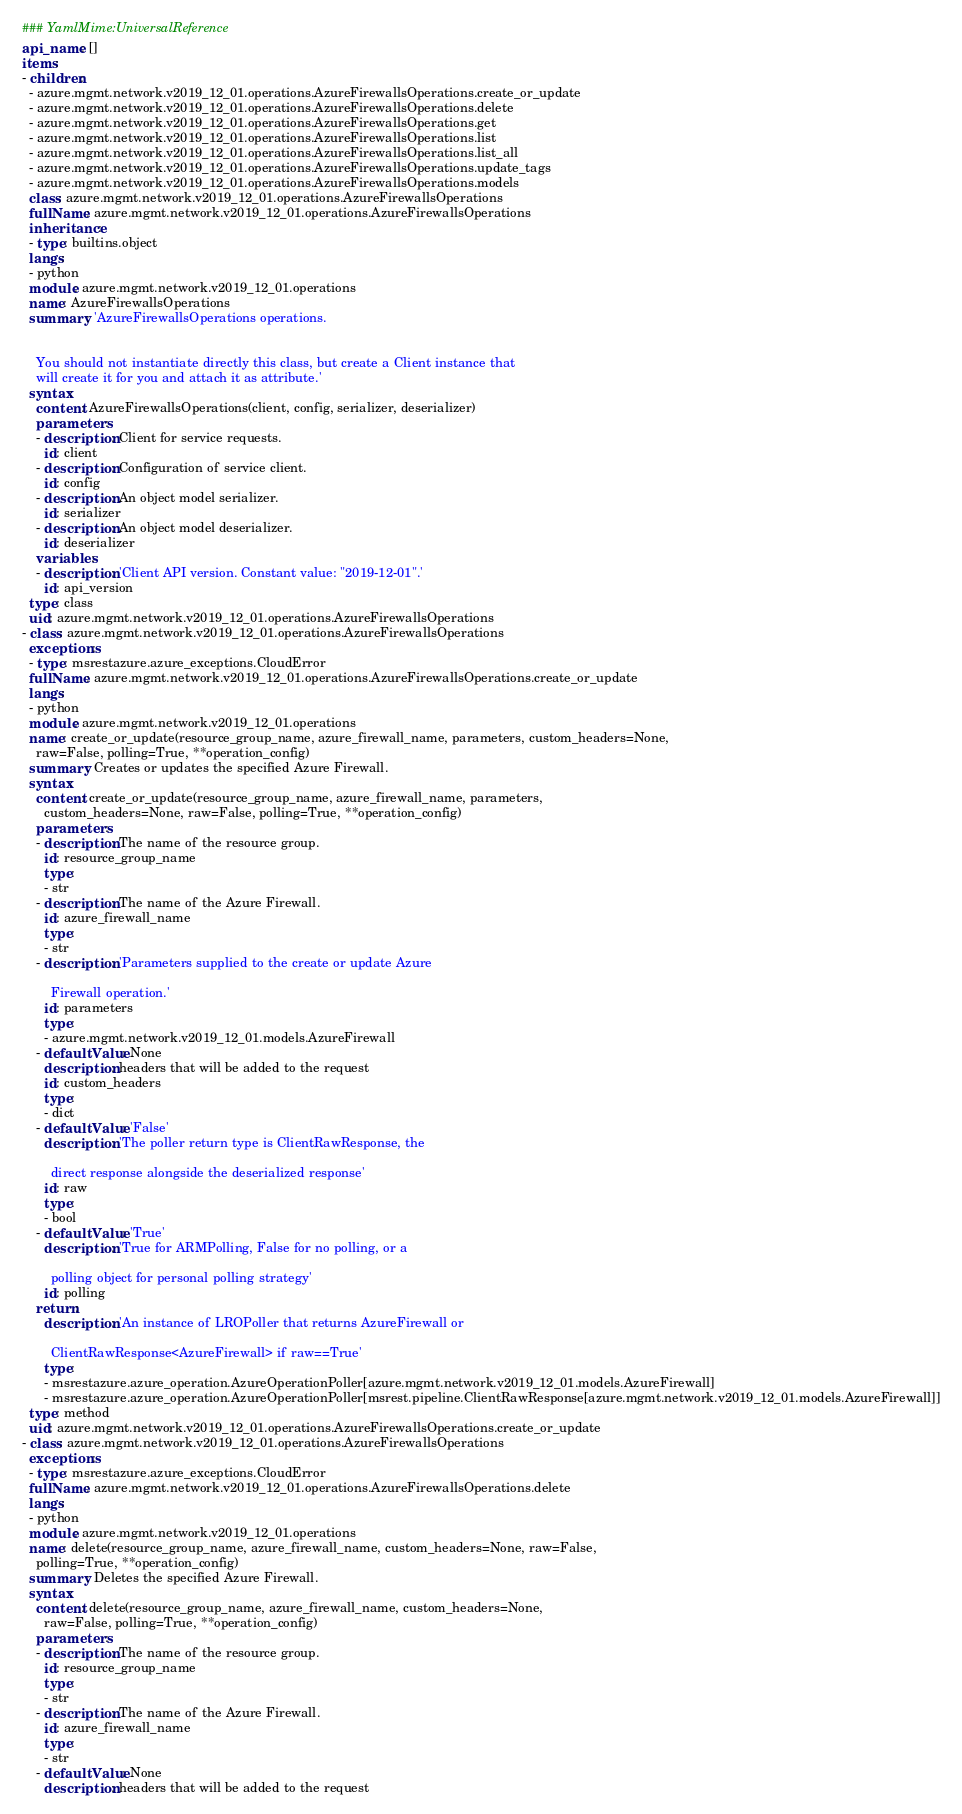Convert code to text. <code><loc_0><loc_0><loc_500><loc_500><_YAML_>### YamlMime:UniversalReference
api_name: []
items:
- children:
  - azure.mgmt.network.v2019_12_01.operations.AzureFirewallsOperations.create_or_update
  - azure.mgmt.network.v2019_12_01.operations.AzureFirewallsOperations.delete
  - azure.mgmt.network.v2019_12_01.operations.AzureFirewallsOperations.get
  - azure.mgmt.network.v2019_12_01.operations.AzureFirewallsOperations.list
  - azure.mgmt.network.v2019_12_01.operations.AzureFirewallsOperations.list_all
  - azure.mgmt.network.v2019_12_01.operations.AzureFirewallsOperations.update_tags
  - azure.mgmt.network.v2019_12_01.operations.AzureFirewallsOperations.models
  class: azure.mgmt.network.v2019_12_01.operations.AzureFirewallsOperations
  fullName: azure.mgmt.network.v2019_12_01.operations.AzureFirewallsOperations
  inheritance:
  - type: builtins.object
  langs:
  - python
  module: azure.mgmt.network.v2019_12_01.operations
  name: AzureFirewallsOperations
  summary: 'AzureFirewallsOperations operations.


    You should not instantiate directly this class, but create a Client instance that
    will create it for you and attach it as attribute.'
  syntax:
    content: AzureFirewallsOperations(client, config, serializer, deserializer)
    parameters:
    - description: Client for service requests.
      id: client
    - description: Configuration of service client.
      id: config
    - description: An object model serializer.
      id: serializer
    - description: An object model deserializer.
      id: deserializer
    variables:
    - description: 'Client API version. Constant value: "2019-12-01".'
      id: api_version
  type: class
  uid: azure.mgmt.network.v2019_12_01.operations.AzureFirewallsOperations
- class: azure.mgmt.network.v2019_12_01.operations.AzureFirewallsOperations
  exceptions:
  - type: msrestazure.azure_exceptions.CloudError
  fullName: azure.mgmt.network.v2019_12_01.operations.AzureFirewallsOperations.create_or_update
  langs:
  - python
  module: azure.mgmt.network.v2019_12_01.operations
  name: create_or_update(resource_group_name, azure_firewall_name, parameters, custom_headers=None,
    raw=False, polling=True, **operation_config)
  summary: Creates or updates the specified Azure Firewall.
  syntax:
    content: create_or_update(resource_group_name, azure_firewall_name, parameters,
      custom_headers=None, raw=False, polling=True, **operation_config)
    parameters:
    - description: The name of the resource group.
      id: resource_group_name
      type:
      - str
    - description: The name of the Azure Firewall.
      id: azure_firewall_name
      type:
      - str
    - description: 'Parameters supplied to the create or update Azure

        Firewall operation.'
      id: parameters
      type:
      - azure.mgmt.network.v2019_12_01.models.AzureFirewall
    - defaultValue: None
      description: headers that will be added to the request
      id: custom_headers
      type:
      - dict
    - defaultValue: 'False'
      description: 'The poller return type is ClientRawResponse, the

        direct response alongside the deserialized response'
      id: raw
      type:
      - bool
    - defaultValue: 'True'
      description: 'True for ARMPolling, False for no polling, or a

        polling object for personal polling strategy'
      id: polling
    return:
      description: 'An instance of LROPoller that returns AzureFirewall or

        ClientRawResponse<AzureFirewall> if raw==True'
      type:
      - msrestazure.azure_operation.AzureOperationPoller[azure.mgmt.network.v2019_12_01.models.AzureFirewall]
      - msrestazure.azure_operation.AzureOperationPoller[msrest.pipeline.ClientRawResponse[azure.mgmt.network.v2019_12_01.models.AzureFirewall]]
  type: method
  uid: azure.mgmt.network.v2019_12_01.operations.AzureFirewallsOperations.create_or_update
- class: azure.mgmt.network.v2019_12_01.operations.AzureFirewallsOperations
  exceptions:
  - type: msrestazure.azure_exceptions.CloudError
  fullName: azure.mgmt.network.v2019_12_01.operations.AzureFirewallsOperations.delete
  langs:
  - python
  module: azure.mgmt.network.v2019_12_01.operations
  name: delete(resource_group_name, azure_firewall_name, custom_headers=None, raw=False,
    polling=True, **operation_config)
  summary: Deletes the specified Azure Firewall.
  syntax:
    content: delete(resource_group_name, azure_firewall_name, custom_headers=None,
      raw=False, polling=True, **operation_config)
    parameters:
    - description: The name of the resource group.
      id: resource_group_name
      type:
      - str
    - description: The name of the Azure Firewall.
      id: azure_firewall_name
      type:
      - str
    - defaultValue: None
      description: headers that will be added to the request</code> 